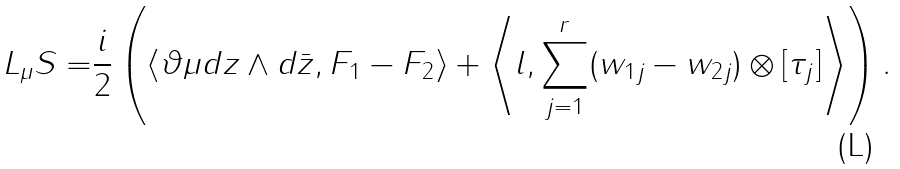<formula> <loc_0><loc_0><loc_500><loc_500>L _ { \mu } S = & \frac { i } { 2 } \left ( \langle \vartheta \mu d z \wedge d \bar { z } , F _ { 1 } - F _ { 2 } \rangle + \left \langle l , \sum _ { j = 1 } ^ { r } ( w _ { 1 j } - w _ { 2 j } ) \otimes [ \tau _ { j } ] \right \rangle \right ) .</formula> 